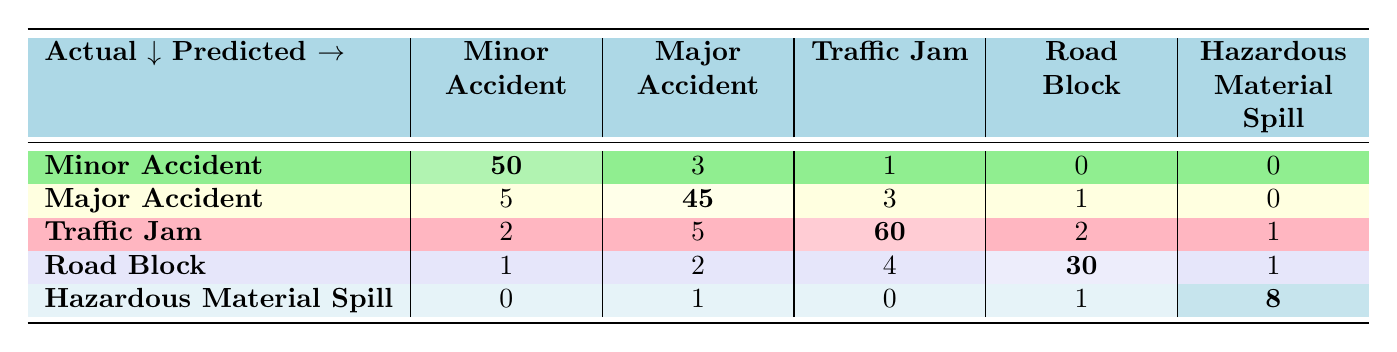What is the number of correctly predicted Minor Accidents? The value corresponding to Minor Accident in the Minor Accident row is highlighted in light green, indicating the correct predictions. Therefore, the number of correctly predicted Minor Accidents is 50.
Answer: 50 How many incidents were incorrectly predicted as Major Accidents? To find this, we look at the row for Major Accident. The values that indicate incorrect predictions (i.e., predictions that were actually Minor Accident, Traffic Jam, Road Block, or Hazardous Material Spill) are 5 (from Minor Accident) + 3 (from Traffic Jam) + 1 (from Road Block) + 0 (from Hazardous Material Spill), giving us a total of 9.
Answer: 9 What is the total number of incidents classified as Traffic Jam? To find this, we look at the entire column for Traffic Jam in the predicted section. The values are 1 (from Minor Accident) + 5 (from Major Accident) + 60 (from Traffic Jam, true positive) + 2 (from Road Block) + 1 (from Hazardous Material Spill), totaling 69.
Answer: 69 Is the number of correctly predicted Road Block incidents greater than that of HazMat Spill incidents? We find the correct predictions for Road Block, which is 30, and for HazMat Spill, which is 8. Since 30 is greater than 8, the statement is true.
Answer: Yes What percentage of all Major Accident occurrences were correctly classified? First, the total count of Major Accidents is the sum of all values in the Major Accident row: 5 + 45 + 3 + 1 + 0 = 54. The correctly classified Major Accidents is the highlighted value, which is 45. The percentage is (45/54) * 100 = 83.33%.
Answer: 83.33% How many incidents were classified as hazards in total, including roadblocks and hazardous spills? To determine this, we add up the total counts for Road Block (30) and Hazardous Material Spill (8), which totals 38.
Answer: 38 Which incident type had the highest number of misclassified predictions? To identify this, we analyze the misclassifications across all rows. The Traffic Jam row has 5 (Major Accident) + 2 (Road Block) + 1 (Hazardous Material Spill) = 8 misclassifications, which is the highest compared to others.
Answer: Traffic Jam What is the overall accuracy of the classification for all incident types? We calculate the total correctly predicted cases: 50 (Minor Accident) + 45 (Major Accident) + 60 (Traffic Jam) + 30 (Road Block) + 8 (HazMat Spill) = 193. The total predictions made is the sum of all values: 50 + 5 + 2 + 3 + 1 + 45 + 3 + 5 + 1 + 2 + 60 + 4 + 2 + 1 + 0 + 8 = 227. The accuracy is (193/227) * 100 = 85.01%.
Answer: 85.01% 